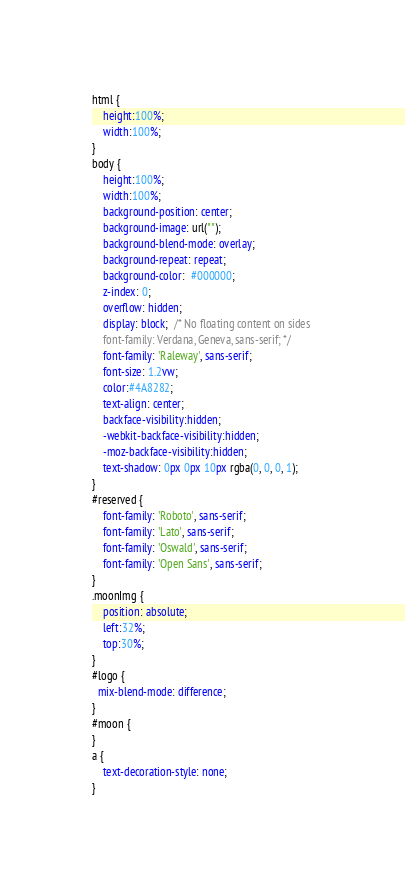Convert code to text. <code><loc_0><loc_0><loc_500><loc_500><_CSS_>html {
	height:100%;
	width:100%;
}
body {
	height:100%;
	width:100%;
	background-position: center;
	background-image: url("");
	background-blend-mode: overlay;
	background-repeat: repeat;
	background-color:  #000000; 
	z-index: 0;
	overflow: hidden;
	display: block;  /* No floating content on sides 
	font-family: Verdana, Geneva, sans-serif; */
    font-family: 'Raleway', sans-serif;
	font-size: 1.2vw;
	color:#4A8282;
	text-align: center;
	backface-visibility:hidden;
	-webkit-backface-visibility:hidden; 
	-moz-backface-visibility:hidden; 
	text-shadow: 0px 0px 10px rgba(0, 0, 0, 1);
}
#reserved {
    font-family: 'Roboto', sans-serif;
    font-family: 'Lato', sans-serif;
    font-family: 'Oswald', sans-serif;
    font-family: 'Open Sans', sans-serif;
}
.moonImg {
	position: absolute;
	left:32%;
	top:30%;
}
#logo {
  mix-blend-mode: difference;
}
#moon {
}
a {
	text-decoration-style: none;
}
</code> 